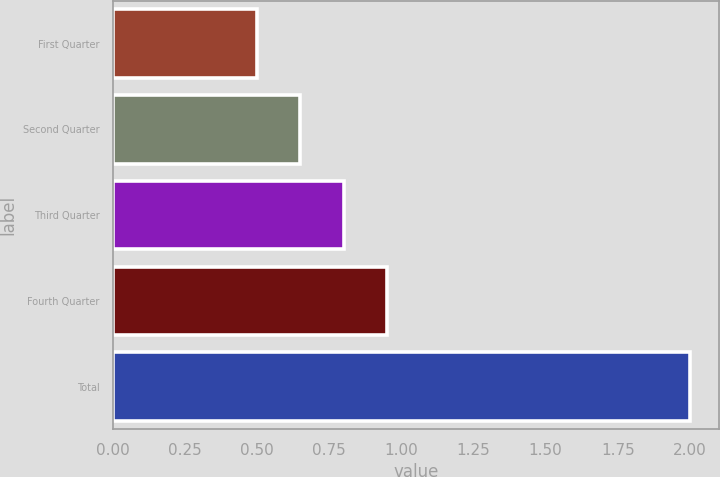Convert chart to OTSL. <chart><loc_0><loc_0><loc_500><loc_500><bar_chart><fcel>First Quarter<fcel>Second Quarter<fcel>Third Quarter<fcel>Fourth Quarter<fcel>Total<nl><fcel>0.5<fcel>0.65<fcel>0.8<fcel>0.95<fcel>2<nl></chart> 